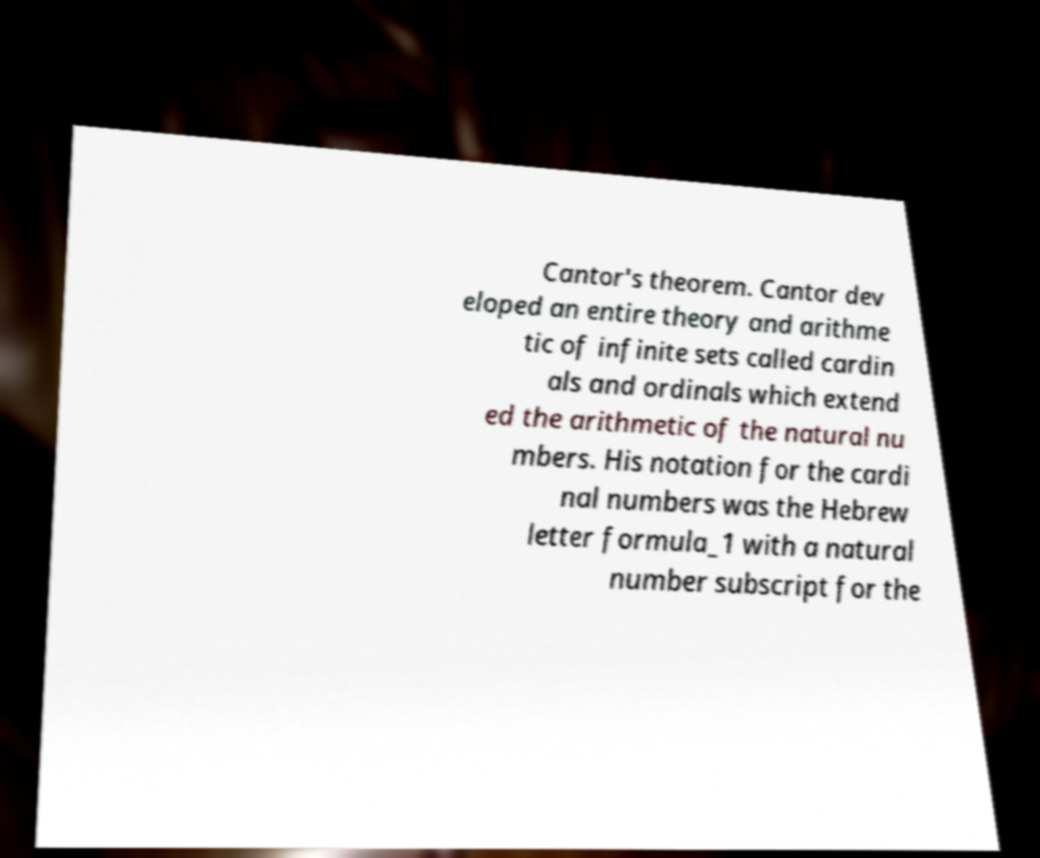What messages or text are displayed in this image? I need them in a readable, typed format. Cantor's theorem. Cantor dev eloped an entire theory and arithme tic of infinite sets called cardin als and ordinals which extend ed the arithmetic of the natural nu mbers. His notation for the cardi nal numbers was the Hebrew letter formula_1 with a natural number subscript for the 